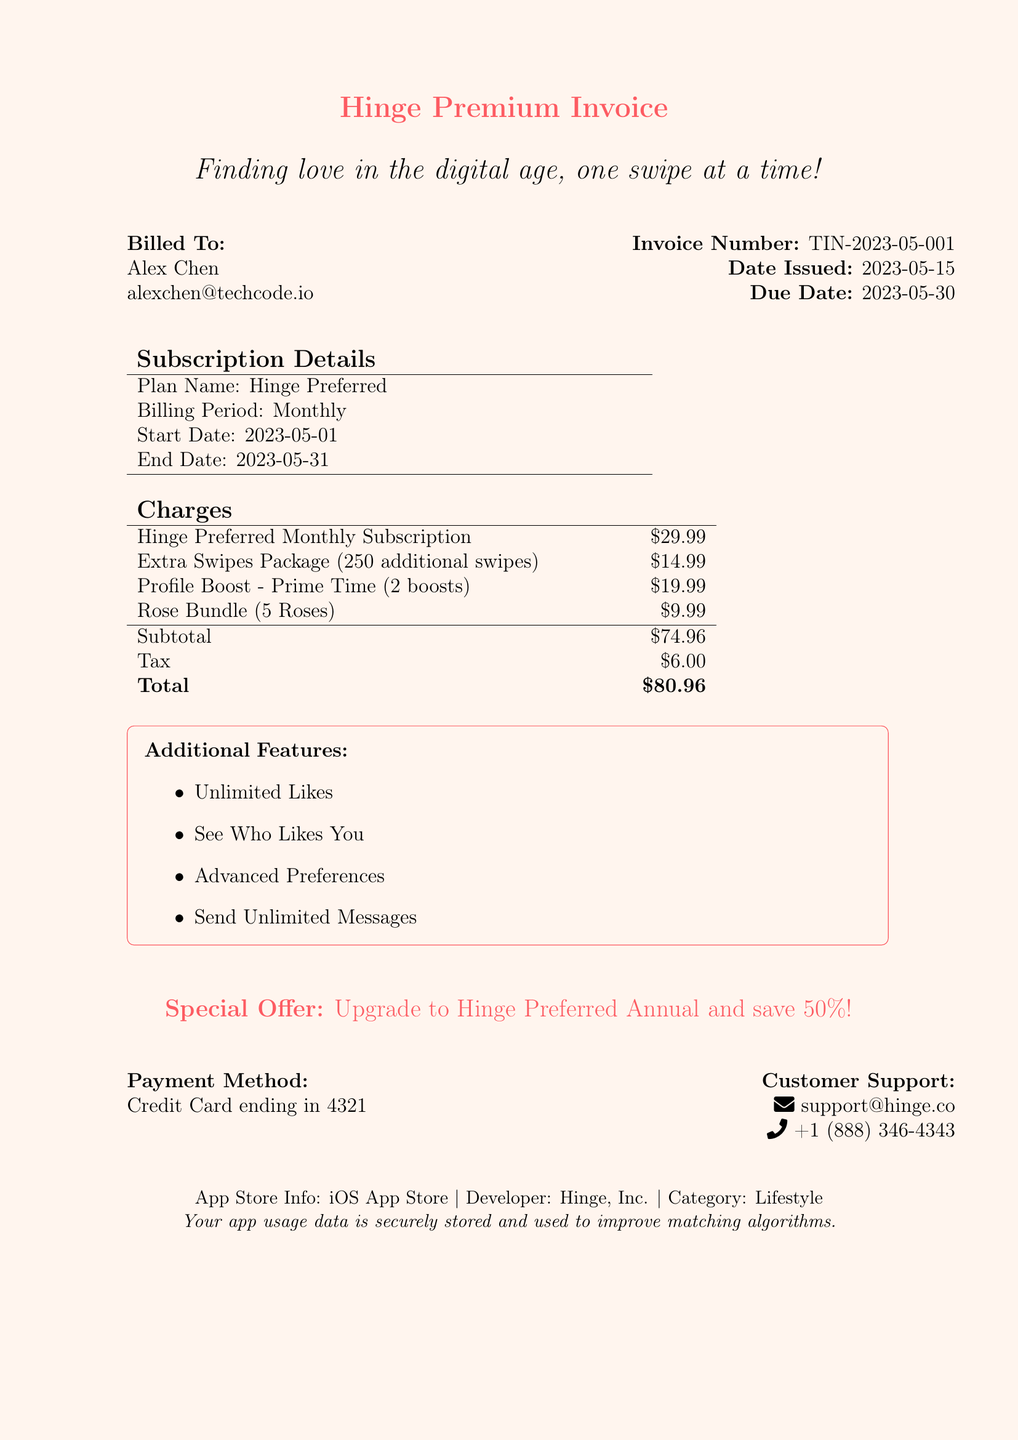What is the invoice number? The invoice number is a unique identifier for the document, which is TIN-2023-05-001.
Answer: TIN-2023-05-001 What is the customer name? The customer name is specified in the document under "Billed To," which is Alex Chen.
Answer: Alex Chen What is the total amount due? The total amount is calculated as the subtotal plus tax, which totals to $80.96.
Answer: $80.96 How many extra swipes are included in the package? The document states that the Extra Swipes Package includes 250 additional swipes.
Answer: 250 What is the special offer available? The special offer outlined in the invoice is for upgrading to Hinge Preferred Annual and saving 50%.
Answer: Upgrade to Hinge Preferred Annual and save 50%! What is the payment method used? The payment method is noted as a Credit Card, with the last four digits provided.
Answer: Credit Card ending in 4321 What is the subtotal amount before tax? The subtotal is calculated from all charges listed before tax is applied, which is $74.96.
Answer: $74.96 How many profile boosts are purchased? The invoice specifies that 2 Profile Boosts were included in the charges.
Answer: 2 What additional features are provided with the subscription? The document lists four additional features included, such as Unlimited Likes.
Answer: Unlimited Likes, See Who Likes You, Advanced Preferences, Send Unlimited Messages 